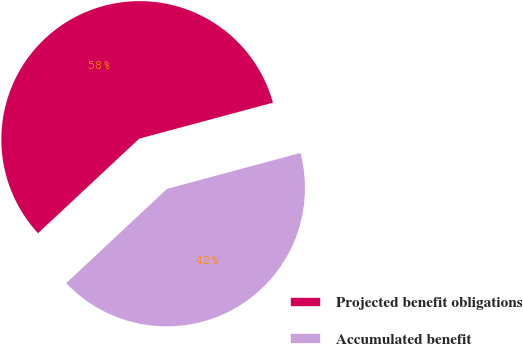<chart> <loc_0><loc_0><loc_500><loc_500><pie_chart><fcel>Projected benefit obligations<fcel>Accumulated benefit<nl><fcel>57.78%<fcel>42.22%<nl></chart> 